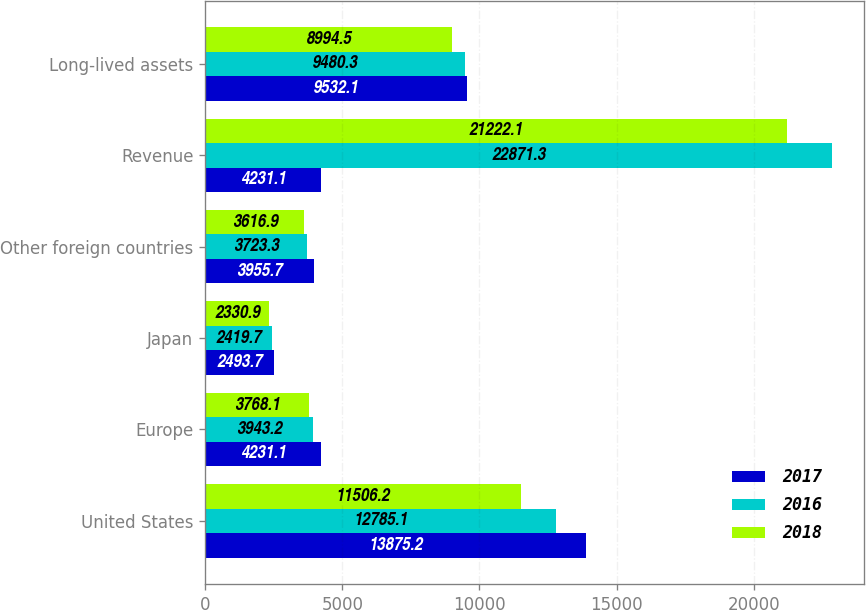Convert chart. <chart><loc_0><loc_0><loc_500><loc_500><stacked_bar_chart><ecel><fcel>United States<fcel>Europe<fcel>Japan<fcel>Other foreign countries<fcel>Revenue<fcel>Long-lived assets<nl><fcel>2017<fcel>13875.2<fcel>4231.1<fcel>2493.7<fcel>3955.7<fcel>4231.1<fcel>9532.1<nl><fcel>2016<fcel>12785.1<fcel>3943.2<fcel>2419.7<fcel>3723.3<fcel>22871.3<fcel>9480.3<nl><fcel>2018<fcel>11506.2<fcel>3768.1<fcel>2330.9<fcel>3616.9<fcel>21222.1<fcel>8994.5<nl></chart> 